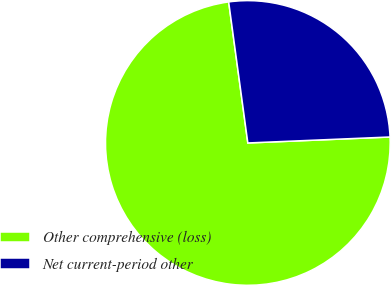<chart> <loc_0><loc_0><loc_500><loc_500><pie_chart><fcel>Other comprehensive (loss)<fcel>Net current-period other<nl><fcel>73.52%<fcel>26.48%<nl></chart> 